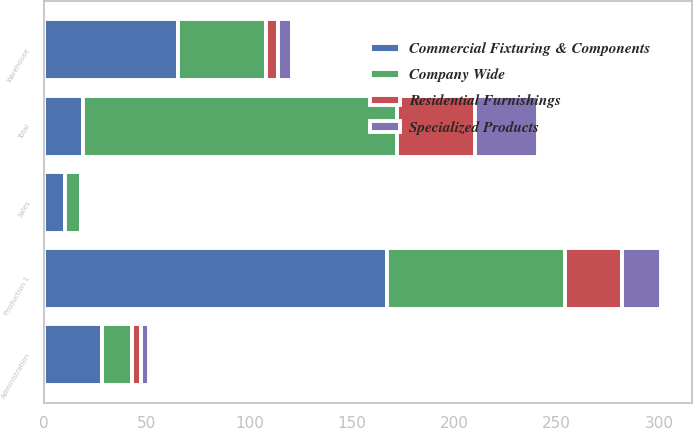<chart> <loc_0><loc_0><loc_500><loc_500><stacked_bar_chart><ecel><fcel>Production 1<fcel>Warehouse<fcel>Sales<fcel>Administration<fcel>Total<nl><fcel>Commercial Fixturing & Components<fcel>167<fcel>65<fcel>10<fcel>28<fcel>19<nl><fcel>Company Wide<fcel>87<fcel>43<fcel>8<fcel>15<fcel>153<nl><fcel>Residential Furnishings<fcel>28<fcel>6<fcel>0<fcel>4<fcel>38<nl><fcel>Specialized Products<fcel>19<fcel>7<fcel>1<fcel>4<fcel>31<nl></chart> 